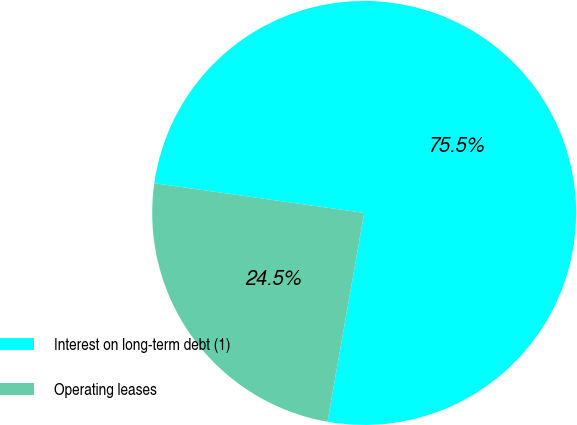Convert chart to OTSL. <chart><loc_0><loc_0><loc_500><loc_500><pie_chart><fcel>Interest on long-term debt (1)<fcel>Operating leases<nl><fcel>75.53%<fcel>24.47%<nl></chart> 